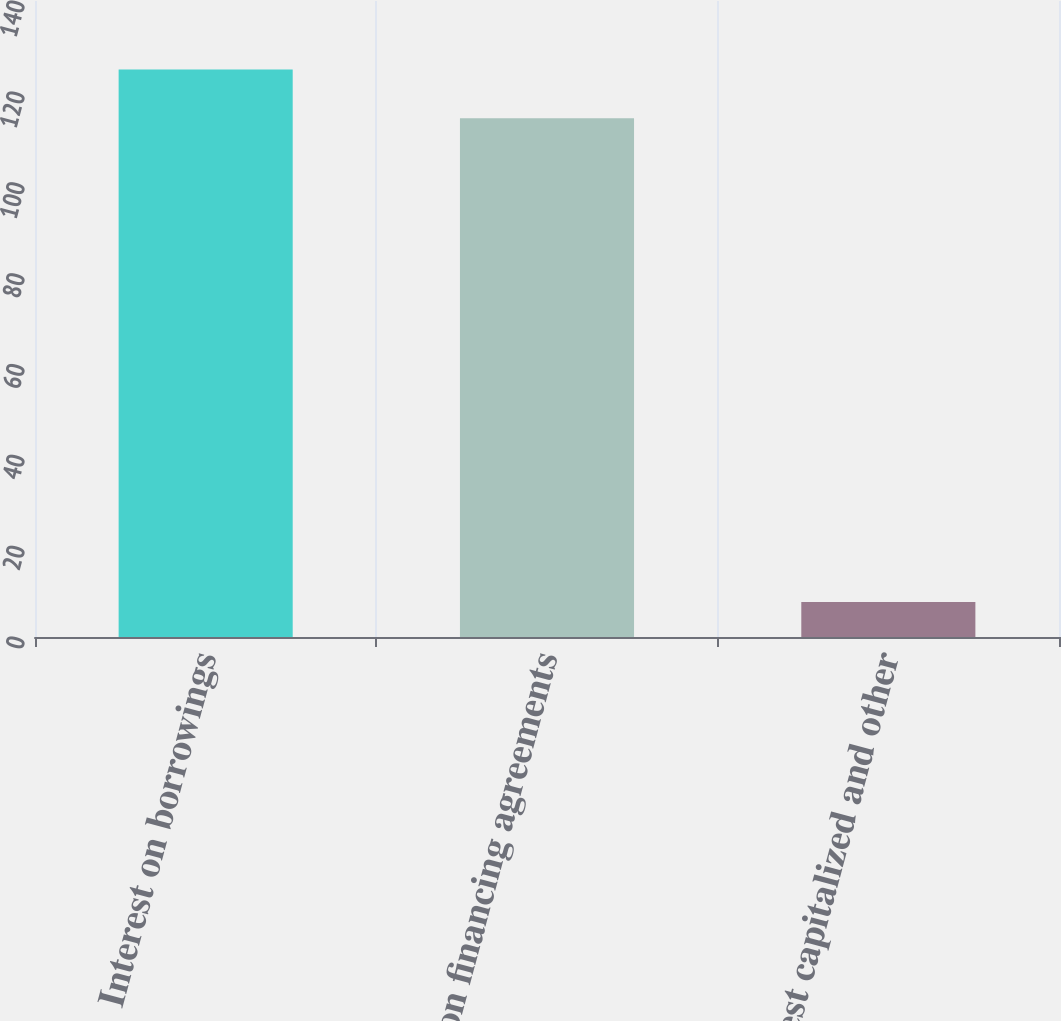Convert chart to OTSL. <chart><loc_0><loc_0><loc_500><loc_500><bar_chart><fcel>Interest on borrowings<fcel>Fees on financing agreements<fcel>Interest capitalized and other<nl><fcel>124.91<fcel>114.2<fcel>7.7<nl></chart> 